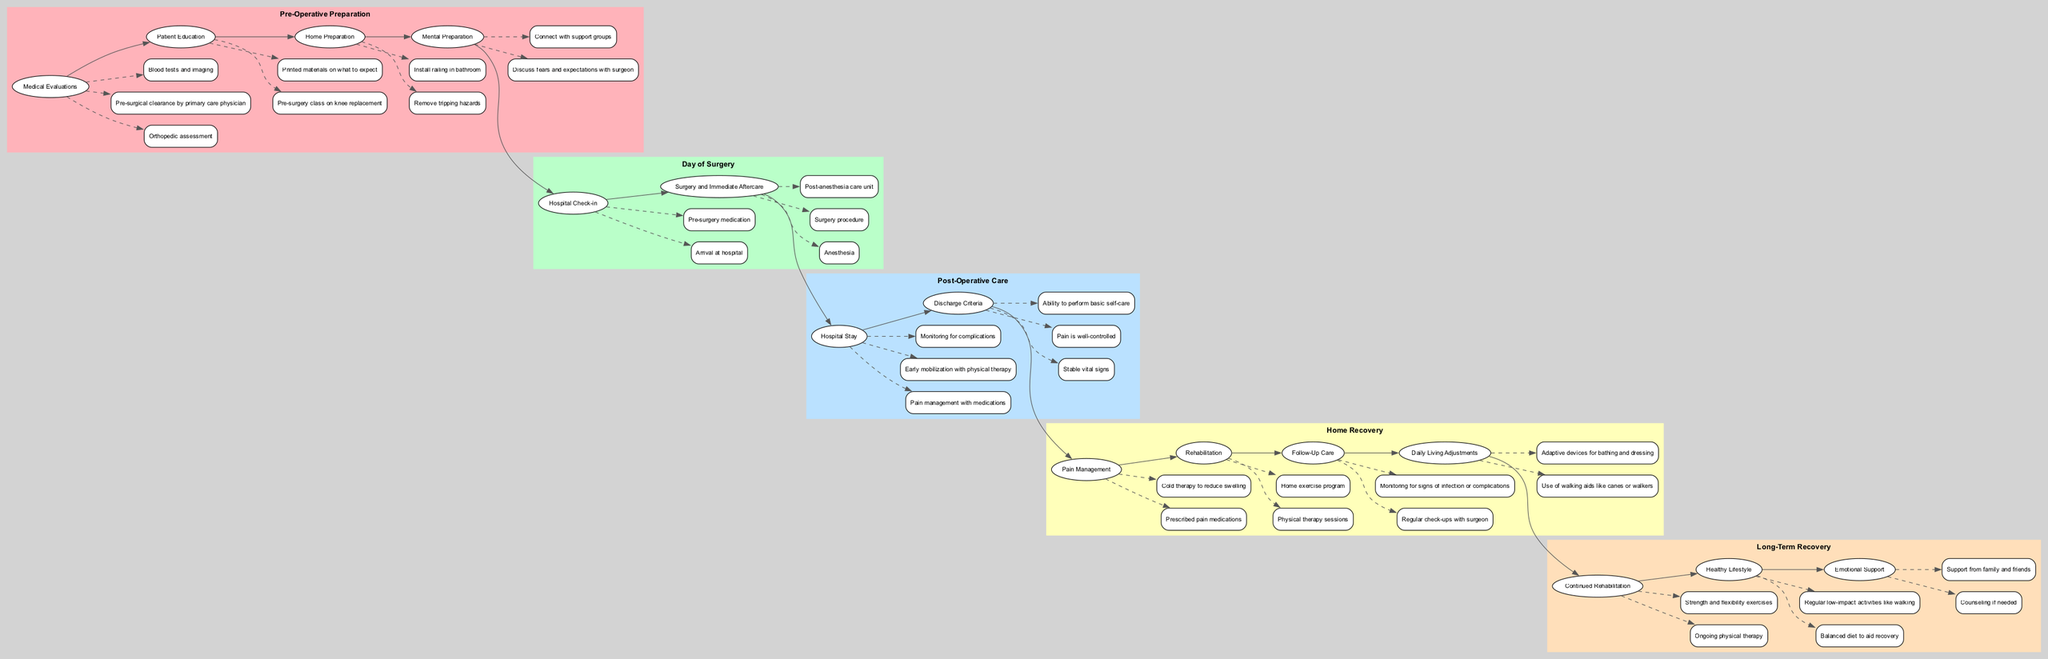What are the components of the "Post-Operative Care" phase? The "Post-Operative Care" phase includes "Hospital Stay" and "Discharge Criteria." This can be found in the diagram, where nodes representing these components are present.
Answer: Hospital Stay, Discharge Criteria How many actions are listed under "Day of Surgery"? Under the "Day of Surgery" phase, there are three actions: "Arrival at hospital," "Pre-surgery medication," "Anesthesia," "Surgery procedure," and "Post-anesthesia care unit." So, there is a total of five actions listed.
Answer: 5 What action follows "Pre-surgery medication"? In the "Day of Surgery" phase, "Pre-surgery medication" is followed by "Anesthesia." By following the flow of the diagram, it is clear that these two nodes are sequential.
Answer: Anesthesia What is the last step in "Home Recovery"? The last step in the "Home Recovery" phase is "Adaptive devices for bathing and dressing." This is determined by looking at the order of actions listed under this phase.
Answer: Adaptive devices for bathing and dressing What is necessary for discharge according to "Discharge Criteria"? For discharge, the patient must have stable vital signs, pain that is well-controlled, and the ability to perform basic self-care. These criteria are explicitly laid out in the diagram's "Post-Operative Care" section.
Answer: Stable vital signs, pain is well-controlled, ability to perform basic self-care What comes after "Early mobilization with physical therapy" in "Hospital Stay"? The sequence shows that after "Early mobilization with physical therapy," the next action is "Monitoring for complications." This follows from the ordered path of actions in the diagram.
Answer: Monitoring for complications How does "Rehabilitation" in "Home Recovery" link to "Continued Rehabilitation" in "Long-Term Recovery"? "Rehabilitation" actions, such as "Physical therapy sessions," lead directly to "Continued Rehabilitation," where "Ongoing physical therapy" is mentioned. This indicates a continual process from home recovery to long-term recovery.
Answer: Ongoing physical therapy What is the purpose of "Mental Preparation" before surgery? "Mental Preparation" includes discussing fears and expectations, which helps to ease anxiety related to the surgery experience. This is reflected in the "Pre-Operative Preparation" section of the diagram.
Answer: Discuss fears and expectations with surgeon 